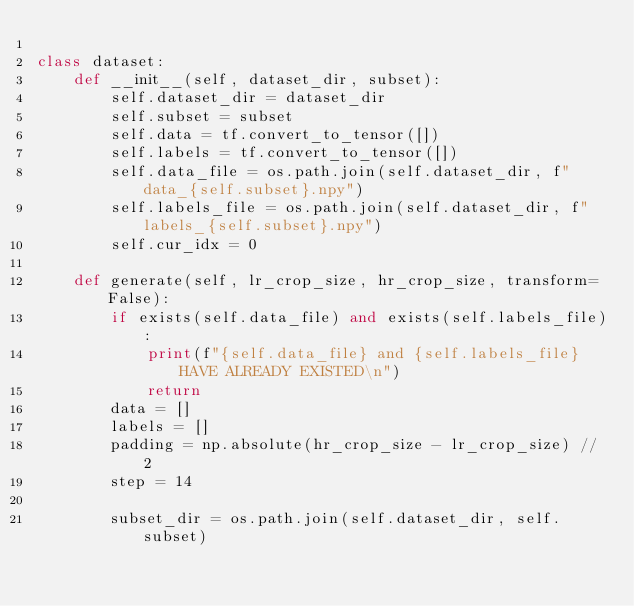<code> <loc_0><loc_0><loc_500><loc_500><_Python_>
class dataset:
    def __init__(self, dataset_dir, subset):
        self.dataset_dir = dataset_dir
        self.subset = subset
        self.data = tf.convert_to_tensor([])
        self.labels = tf.convert_to_tensor([])
        self.data_file = os.path.join(self.dataset_dir, f"data_{self.subset}.npy")
        self.labels_file = os.path.join(self.dataset_dir, f"labels_{self.subset}.npy")
        self.cur_idx = 0
    
    def generate(self, lr_crop_size, hr_crop_size, transform=False):      
        if exists(self.data_file) and exists(self.labels_file):
            print(f"{self.data_file} and {self.labels_file} HAVE ALREADY EXISTED\n")
            return
        data = []
        labels = []
        padding = np.absolute(hr_crop_size - lr_crop_size) // 2
        step = 14

        subset_dir = os.path.join(self.dataset_dir, self.subset)</code> 